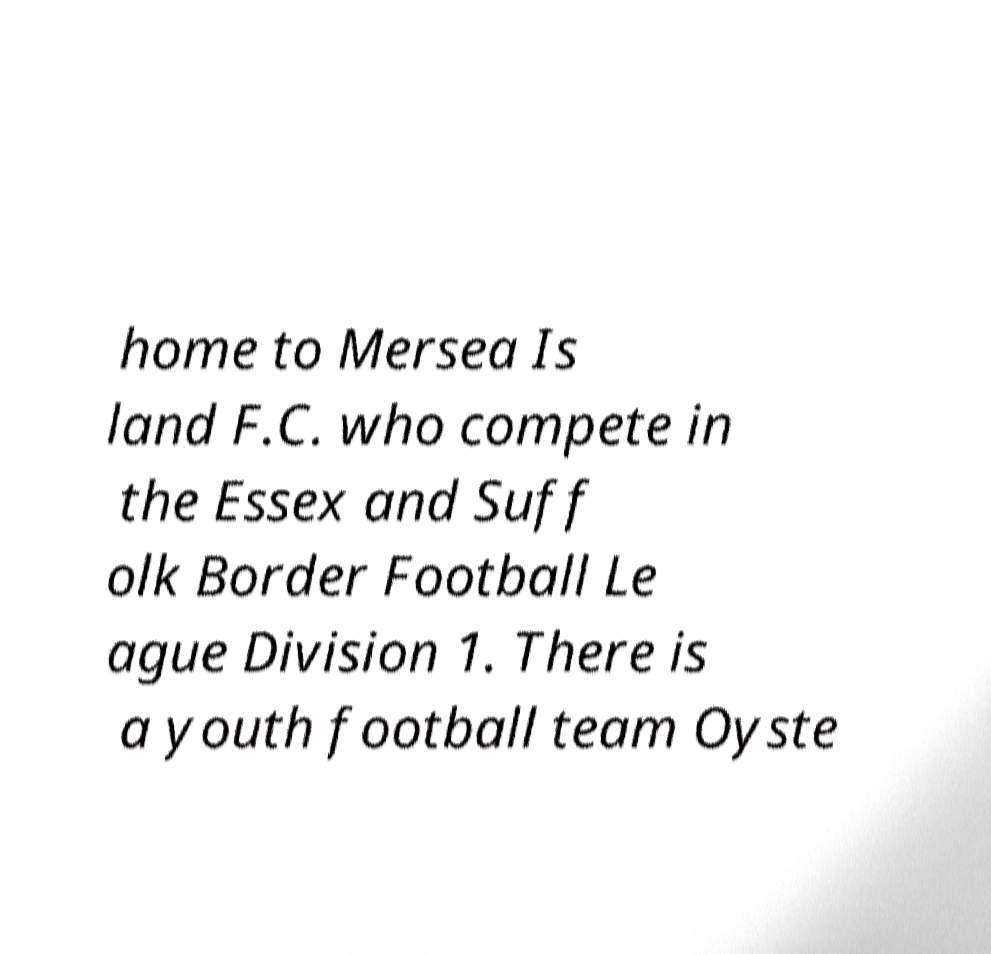Could you extract and type out the text from this image? home to Mersea Is land F.C. who compete in the Essex and Suff olk Border Football Le ague Division 1. There is a youth football team Oyste 